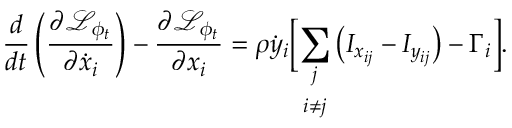Convert formula to latex. <formula><loc_0><loc_0><loc_500><loc_500>\frac { d } { d t } \left ( \frac { \partial \mathcal { L } _ { \phi _ { t } } } { \partial \dot { x } _ { i } } \right ) - \frac { \partial \mathcal { L } _ { \phi _ { t } } } { \partial x _ { i } } = \rho \dot { y } _ { i } \left [ \underset { i \neq j } { \sum _ { j } } \left ( I _ { x _ { i j } } - I _ { y _ { i j } } \right ) - \Gamma _ { i } \right ] .</formula> 